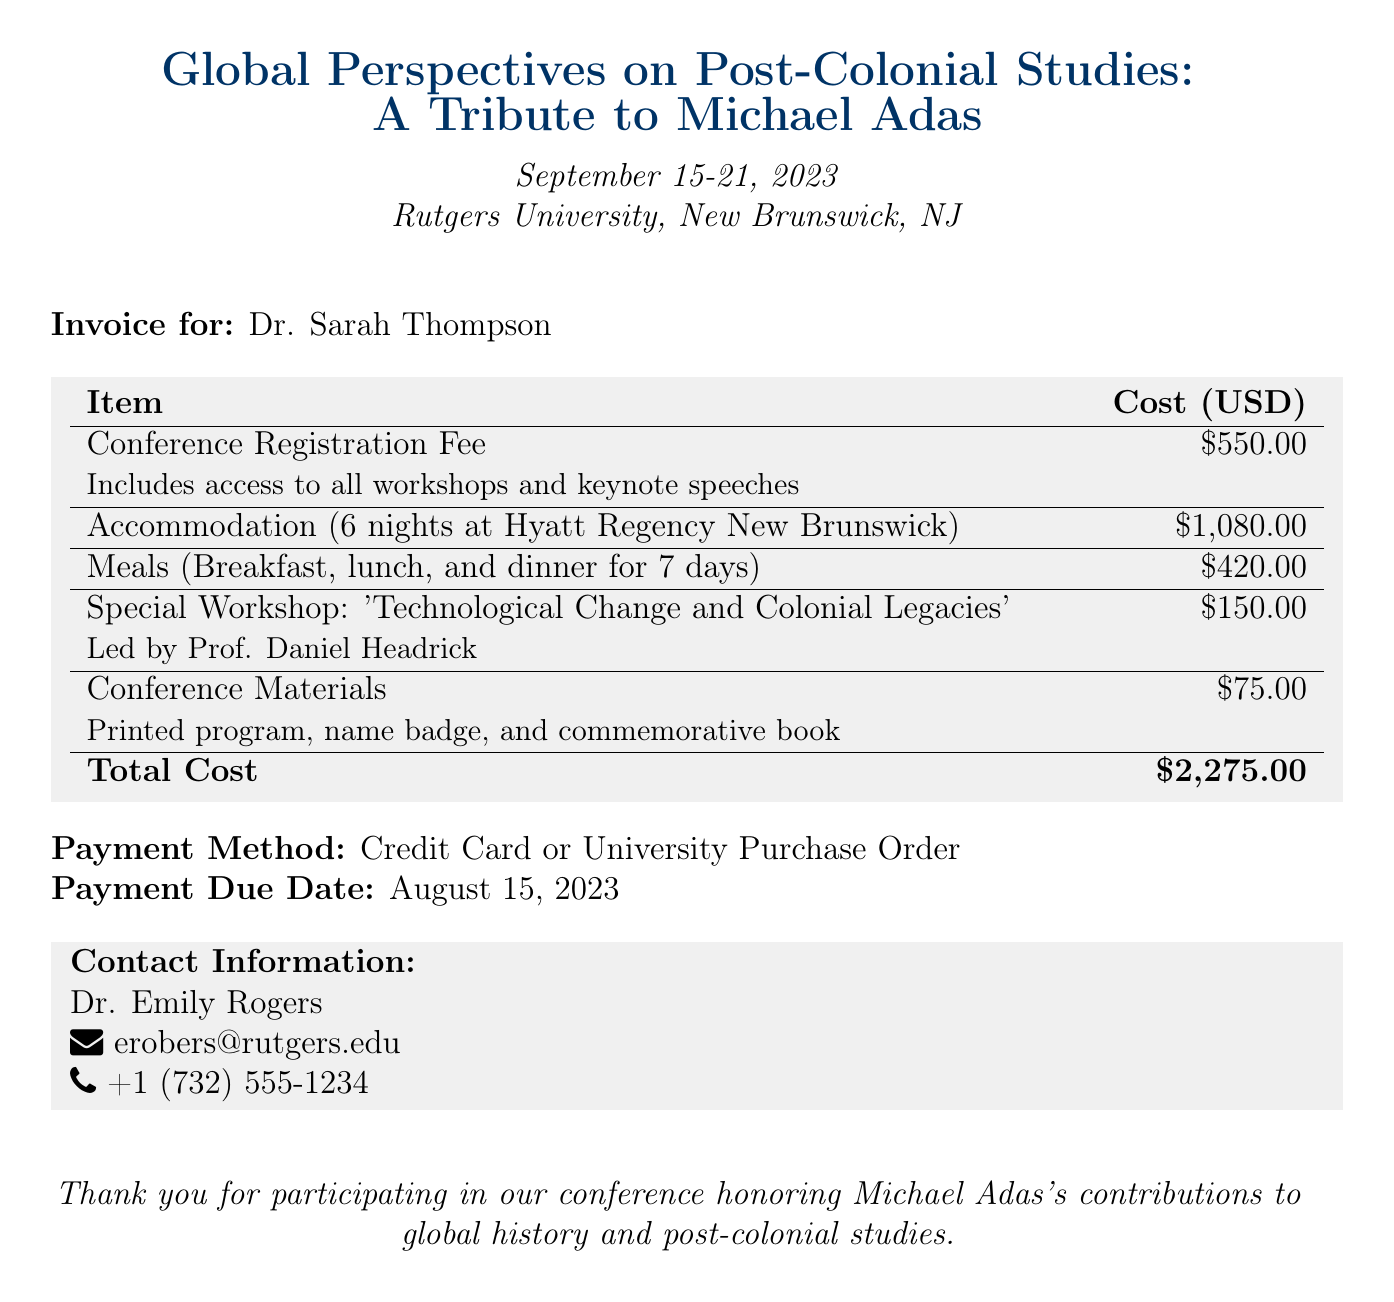what is the total cost? The total cost is the final amount listed in the invoice, which aggregates all the itemized costs.
Answer: $2,275.00 who is the invoice for? The invoice specifies the name of the individual for whom it is directed.
Answer: Dr. Sarah Thompson what is the date range of the conference? The document provides the starting and ending dates of the event.
Answer: September 15-21, 2023 how many nights of accommodation are included? The document specifies the total number of nights booked for accommodation.
Answer: 6 nights what is the cost of the conference registration fee? The invoice details the specific item of the registration fee along with its cost.
Answer: $550.00 who led the special workshop? The document states the name of the person who led the workshop.
Answer: Prof. Daniel Headrick when is the payment due? The invoice specifies the deadline for making the payment.
Answer: August 15, 2023 what is included in the conference materials? The document briefly lists the contents provided in the conference materials.
Answer: Printed program, name badge, and commemorative book what payment methods are accepted? The invoice mentions the available options for making the payment.
Answer: Credit Card or University Purchase Order 